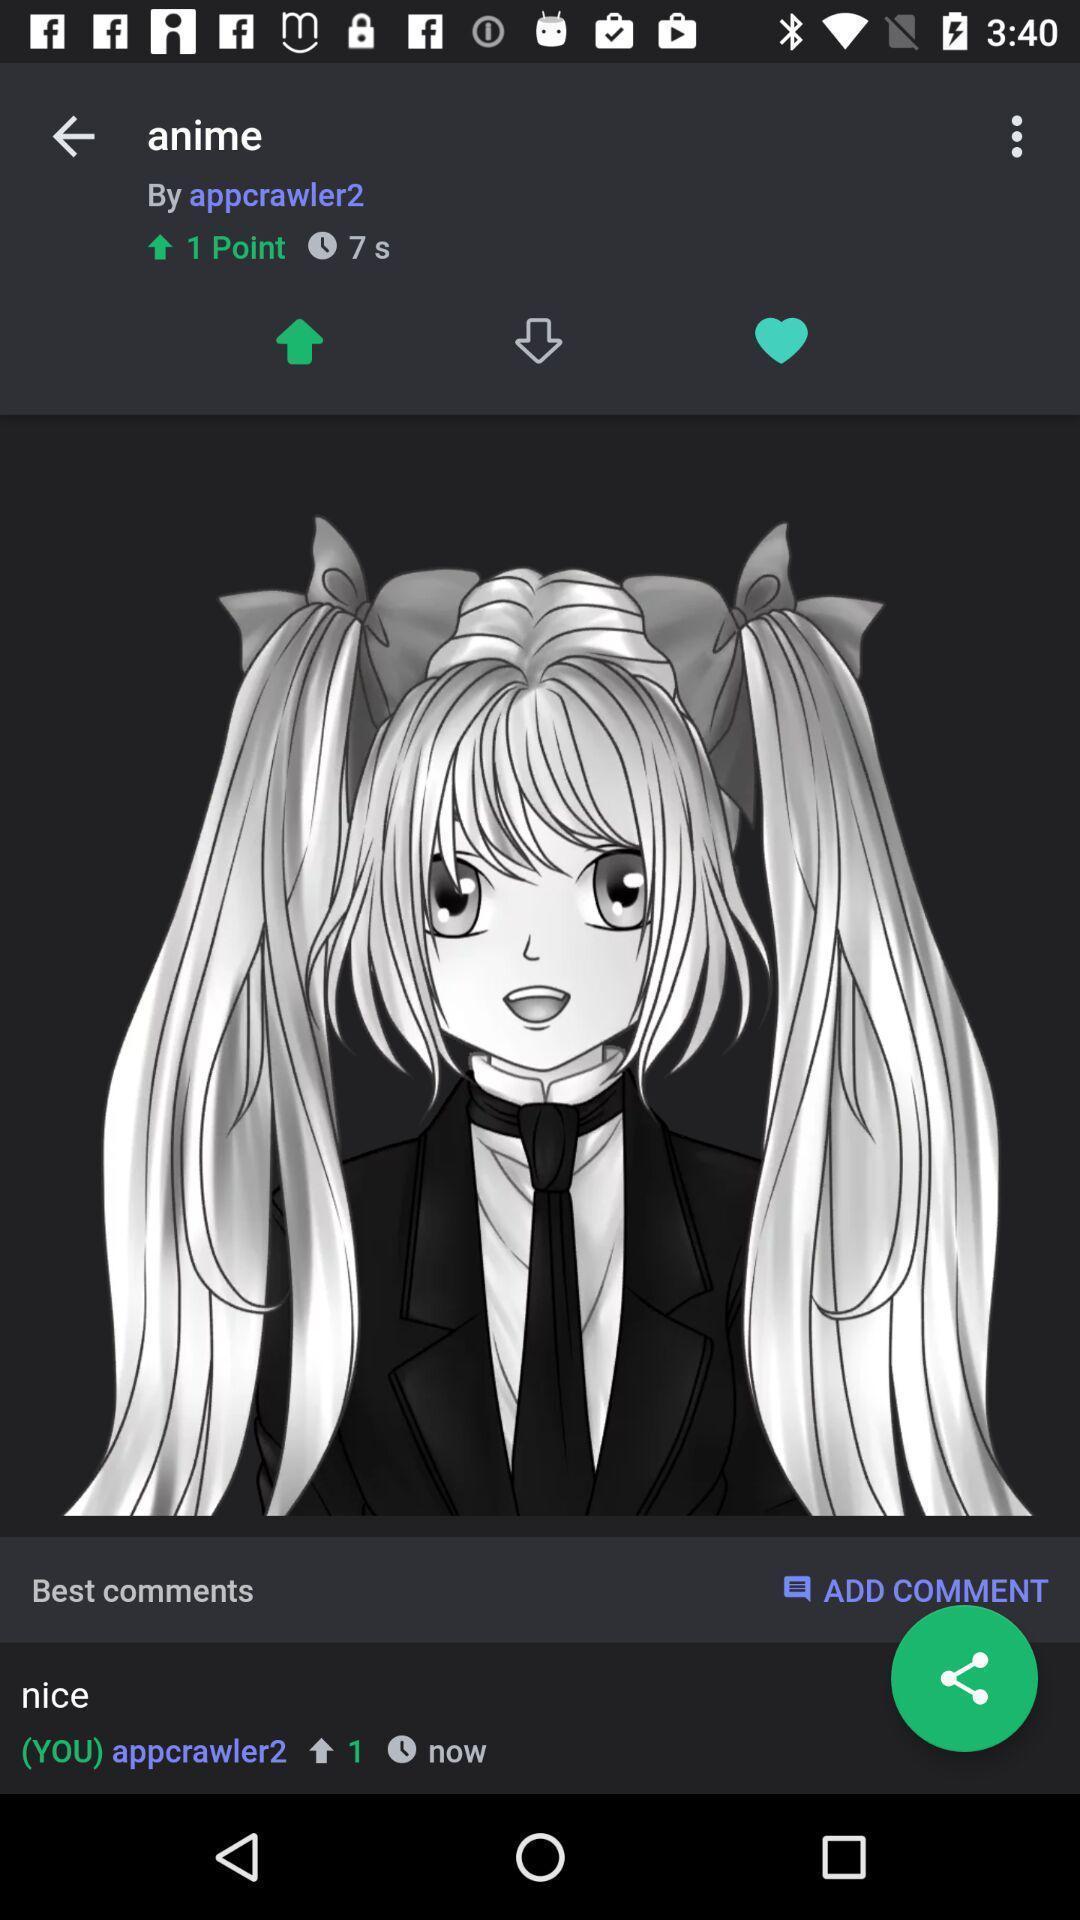Give me a summary of this screen capture. Post of an anime in a social app. 